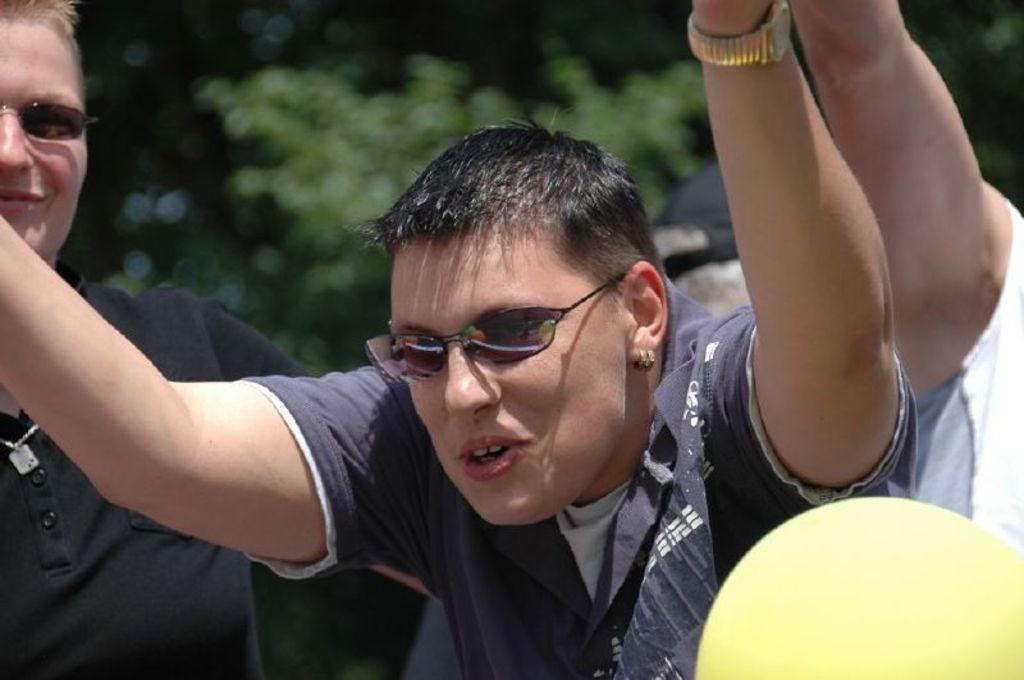Describe this image in one or two sentences. In the image we can see there are people standing and they are wearing sunglasses. 